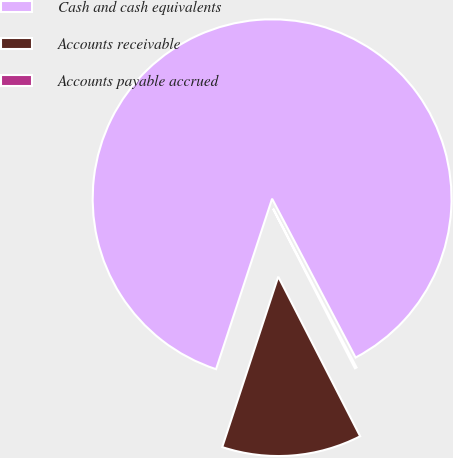Convert chart to OTSL. <chart><loc_0><loc_0><loc_500><loc_500><pie_chart><fcel>Cash and cash equivalents<fcel>Accounts receivable<fcel>Accounts payable accrued<nl><fcel>87.24%<fcel>12.6%<fcel>0.16%<nl></chart> 